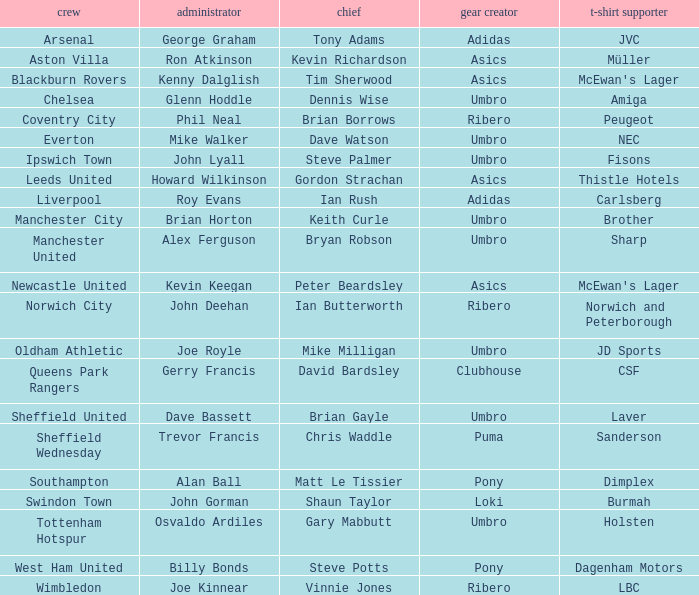Which team has george graham as the manager? Arsenal. 